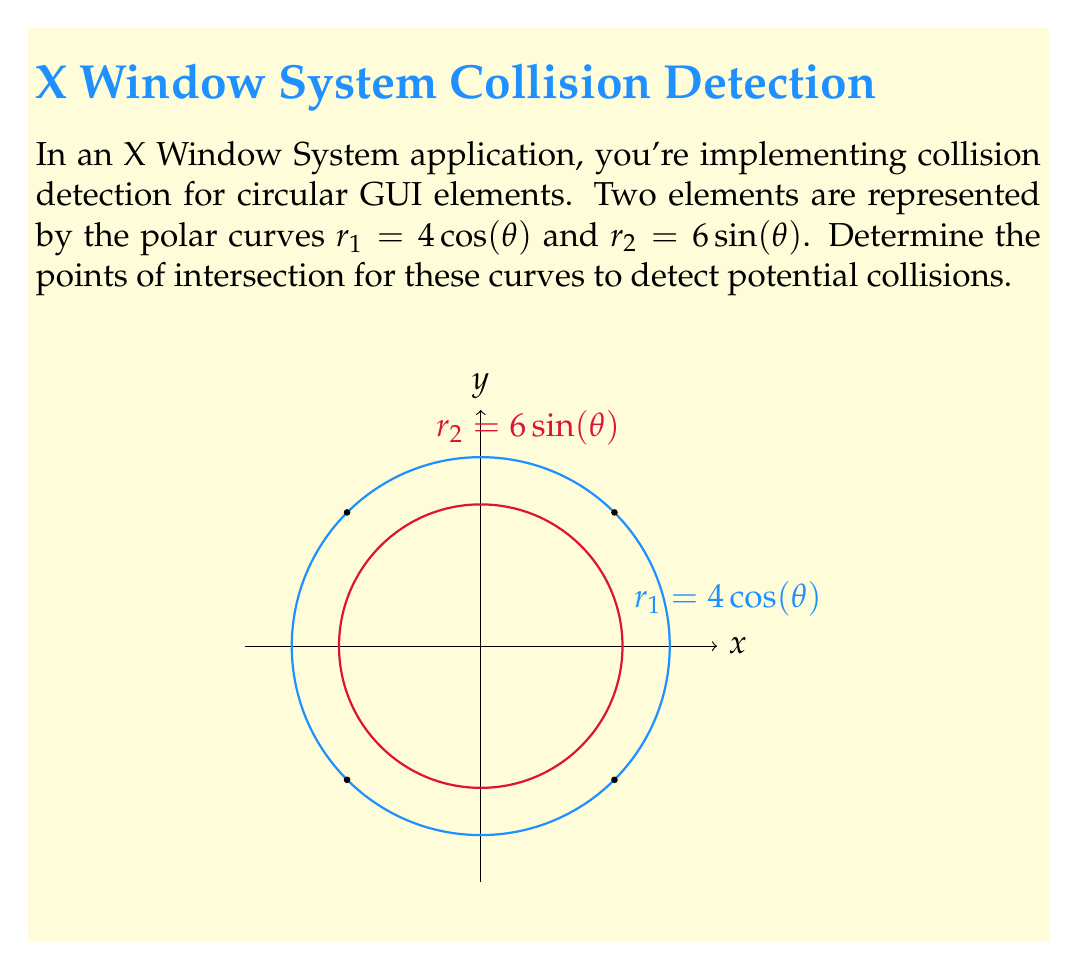What is the answer to this math problem? To find the intersection points, we need to solve the system of equations:

$$r_1 = 4\cos(\theta)$$
$$r_2 = 6\sin(\theta)$$

At the intersection points, $r_1 = r_2$, so:

$$4\cos(\theta) = 6\sin(\theta)$$

Step 1: Divide both sides by $\cos(\theta)$ (assuming $\cos(\theta) \neq 0$):

$$4 = 6\tan(\theta)$$

Step 2: Solve for $\theta$:

$$\tan(\theta) = \frac{2}{3}$$
$$\theta = \arctan(\frac{2}{3})$$

Step 3: Due to the symmetry of sine and cosine, we have four solutions in the range $[0, 2\pi]$:

$$\theta_1 = \arctan(\frac{2}{3})$$
$$\theta_2 = \pi - \arctan(\frac{2}{3})$$
$$\theta_3 = \pi + \arctan(\frac{2}{3})$$
$$\theta_4 = 2\pi - \arctan(\frac{2}{3})$$

Step 4: Calculate $r$ for these $\theta$ values:

$$r = 4\cos(\arctan(\frac{2}{3})) = 4 \cdot \frac{3}{\sqrt{13}} = \frac{12}{\sqrt{13}}$$

Step 5: Convert to Cartesian coordinates:

$$x = r\cos(\theta) = \frac{12}{\sqrt{13}} \cdot \frac{3}{\sqrt{13}} = \frac{36}{13} = 2\sqrt{2}$$
$$y = r\sin(\theta) = \frac{12}{\sqrt{13}} \cdot \frac{2}{\sqrt{13}} = \frac{24}{13} = 2\sqrt{2}$$

The four intersection points are:

$$(2\sqrt{2}, 2\sqrt{2}), (2\sqrt{2}, -2\sqrt{2}), (-2\sqrt{2}, 2\sqrt{2}), (-2\sqrt{2}, -2\sqrt{2})$$
Answer: $(\pm2\sqrt{2}, \pm2\sqrt{2})$ 